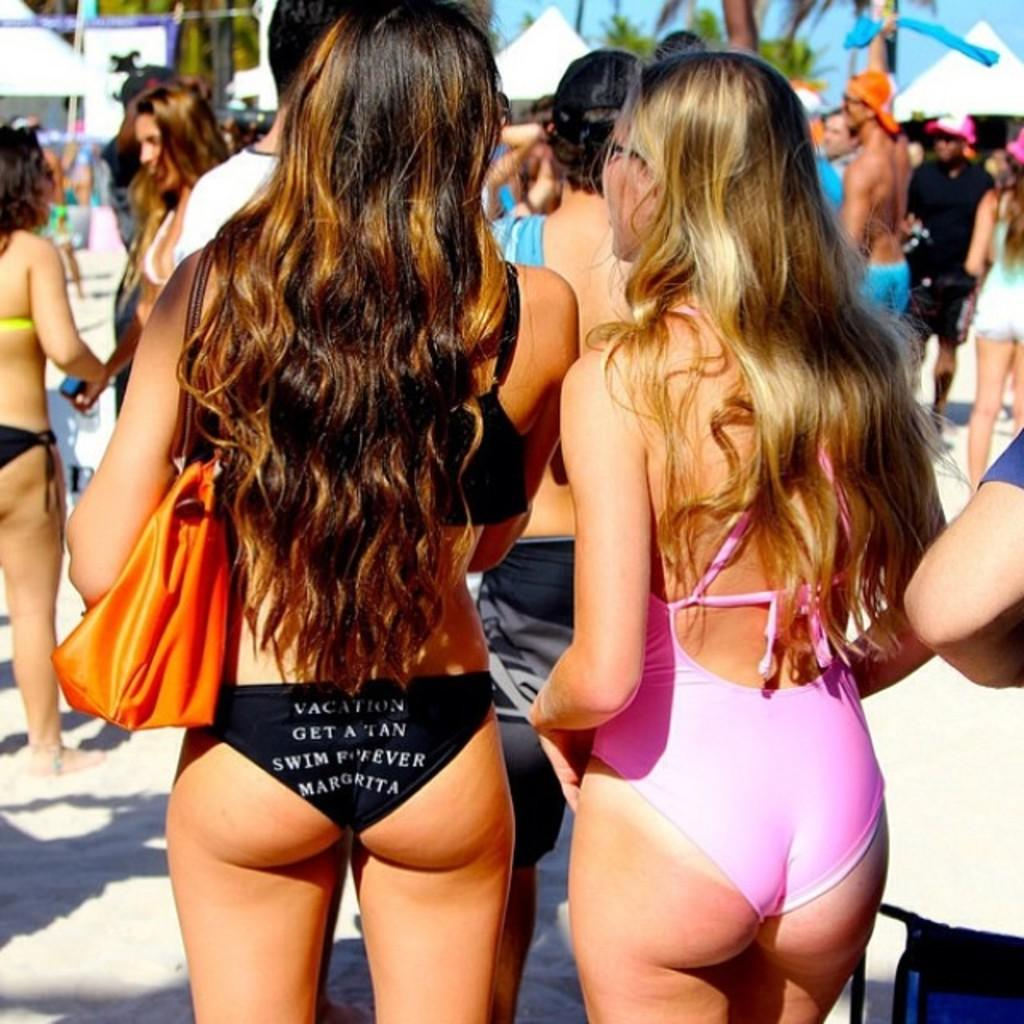How many people are visible in the image? There are people standing in the image, but the exact number is not specified. What is one person holding in the image? One person is carrying a bag in the image. What can be seen in the background of the image? There are tents and trees in the background of the image, as well as the sky. What type of crib is visible in the image? There is no crib present in the image. What is the angle of the route the people are taking in the image? The facts do not mention a route or an angle, so we cannot determine this information from the image. 